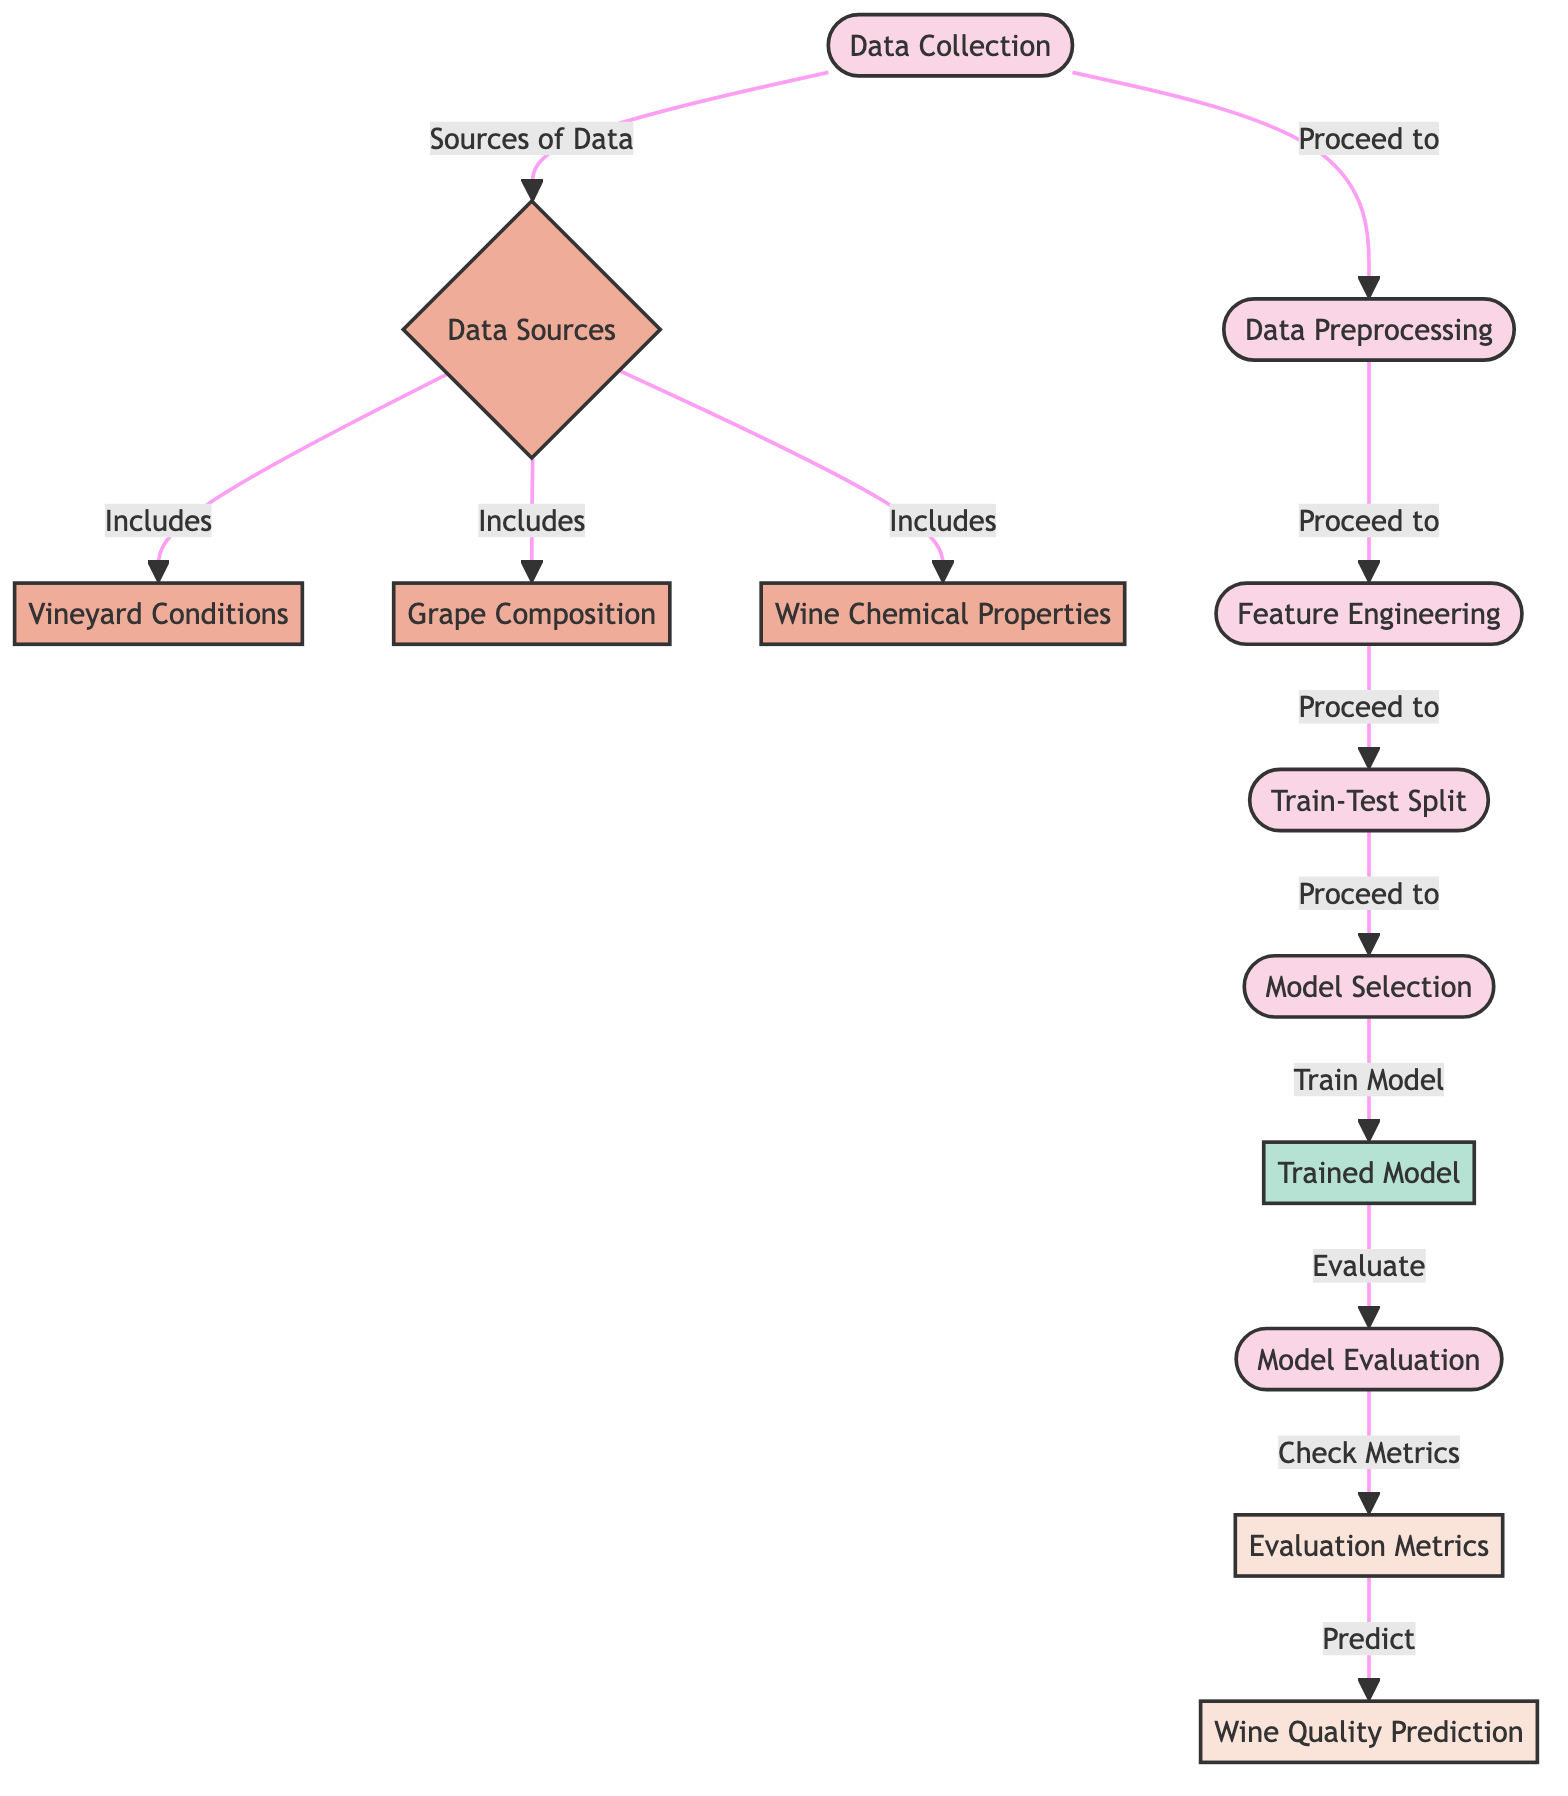What's the first step in the diagram? The first step is "Data Collection," as indicated at the top of the flowchart. It is the initial process before any other actions take place.
Answer: Data Collection How many data sources are identified in the diagram? The diagram lists three data sources: "Vineyard Conditions," "Grape Composition," and "Wine Chemical Properties." Counting these gives a total of three.
Answer: Three What comes after "Data Collection" in the flowchart? After "Data Collection," the next process is "Preprocessing," which is connected directly from "Data Collection" with an arrow indicating the flow.
Answer: Preprocessing Which process directly leads to "Trained Model"? The process that leads directly to "Trained Model" is "Model Selection." This step is key in determining the model that will be trained based on the previous steps.
Answer: Model Selection What is the final output of the diagram? The final output is "Wine Quality Prediction," which is the ultimate goal of the processes shown in the flowchart, representing the prediction achieved after model evaluation.
Answer: Wine Quality Prediction What is the purpose of "Feature Engineering"? "Feature Engineering" serves to enhance the model's input data by creating additional features or modifying existing ones for better model performance. It plays a critical role in improving the outcome.
Answer: Enhance model input How do "Evaluation Metrics" relate to "Model Evaluation"? "Evaluation Metrics" are used to assess the performance of the "Trained Model" during the "Model Evaluation" process, indicating how well the model predicts wine quality.
Answer: Assess performance What type of node is "Wine Chemical Properties"? "Wine Chemical Properties" is classified as a data node, as it is one of the inputs that feed into the data collection process for the machine learning model.
Answer: Data node How many total processing steps are depicted in the diagram? The processing steps are "Data Collection," "Preprocessing," "Feature Engineering," "Train-Test Split," "Model Selection," and "Model Evaluation," totaling six distinct steps in the process.
Answer: Six 